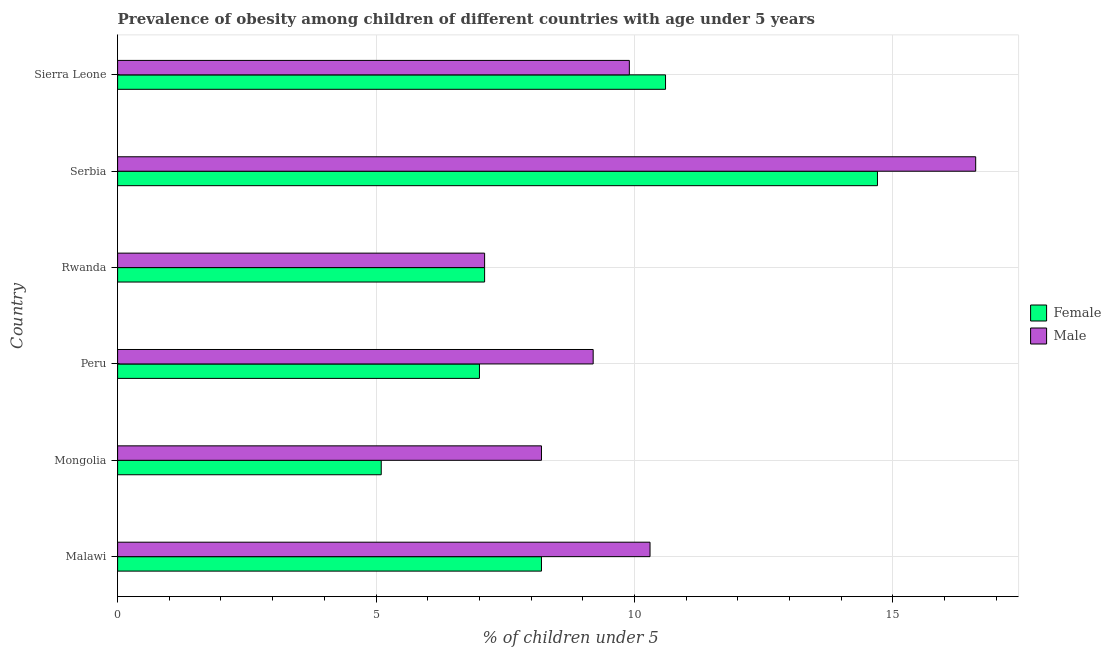How many different coloured bars are there?
Offer a terse response. 2. How many bars are there on the 1st tick from the bottom?
Your answer should be very brief. 2. What is the label of the 6th group of bars from the top?
Provide a short and direct response. Malawi. In how many cases, is the number of bars for a given country not equal to the number of legend labels?
Provide a succinct answer. 0. What is the percentage of obese female children in Malawi?
Ensure brevity in your answer.  8.2. Across all countries, what is the maximum percentage of obese female children?
Give a very brief answer. 14.7. Across all countries, what is the minimum percentage of obese male children?
Give a very brief answer. 7.1. In which country was the percentage of obese male children maximum?
Offer a terse response. Serbia. In which country was the percentage of obese female children minimum?
Offer a very short reply. Mongolia. What is the total percentage of obese female children in the graph?
Make the answer very short. 52.7. What is the difference between the percentage of obese female children in Rwanda and that in Serbia?
Make the answer very short. -7.6. What is the difference between the percentage of obese female children in Serbia and the percentage of obese male children in Malawi?
Ensure brevity in your answer.  4.4. What is the average percentage of obese female children per country?
Provide a short and direct response. 8.78. What is the difference between the percentage of obese female children and percentage of obese male children in Serbia?
Ensure brevity in your answer.  -1.9. What is the ratio of the percentage of obese female children in Peru to that in Rwanda?
Your response must be concise. 0.99. Is the percentage of obese female children in Peru less than that in Rwanda?
Your answer should be very brief. Yes. Is the difference between the percentage of obese female children in Serbia and Sierra Leone greater than the difference between the percentage of obese male children in Serbia and Sierra Leone?
Give a very brief answer. No. What does the 2nd bar from the bottom in Sierra Leone represents?
Your response must be concise. Male. How many bars are there?
Keep it short and to the point. 12. How many countries are there in the graph?
Offer a very short reply. 6. Does the graph contain any zero values?
Your response must be concise. No. How many legend labels are there?
Your answer should be very brief. 2. How are the legend labels stacked?
Ensure brevity in your answer.  Vertical. What is the title of the graph?
Offer a very short reply. Prevalence of obesity among children of different countries with age under 5 years. Does "Merchandise exports" appear as one of the legend labels in the graph?
Ensure brevity in your answer.  No. What is the label or title of the X-axis?
Your response must be concise.  % of children under 5. What is the label or title of the Y-axis?
Ensure brevity in your answer.  Country. What is the  % of children under 5 of Female in Malawi?
Ensure brevity in your answer.  8.2. What is the  % of children under 5 of Male in Malawi?
Your answer should be very brief. 10.3. What is the  % of children under 5 in Female in Mongolia?
Offer a very short reply. 5.1. What is the  % of children under 5 in Male in Mongolia?
Provide a succinct answer. 8.2. What is the  % of children under 5 in Male in Peru?
Give a very brief answer. 9.2. What is the  % of children under 5 of Female in Rwanda?
Your answer should be compact. 7.1. What is the  % of children under 5 in Male in Rwanda?
Offer a terse response. 7.1. What is the  % of children under 5 in Female in Serbia?
Keep it short and to the point. 14.7. What is the  % of children under 5 of Male in Serbia?
Your answer should be very brief. 16.6. What is the  % of children under 5 of Female in Sierra Leone?
Make the answer very short. 10.6. What is the  % of children under 5 in Male in Sierra Leone?
Give a very brief answer. 9.9. Across all countries, what is the maximum  % of children under 5 of Female?
Your response must be concise. 14.7. Across all countries, what is the maximum  % of children under 5 of Male?
Your answer should be compact. 16.6. Across all countries, what is the minimum  % of children under 5 in Female?
Offer a very short reply. 5.1. Across all countries, what is the minimum  % of children under 5 of Male?
Your answer should be compact. 7.1. What is the total  % of children under 5 in Female in the graph?
Make the answer very short. 52.7. What is the total  % of children under 5 of Male in the graph?
Your answer should be compact. 61.3. What is the difference between the  % of children under 5 in Male in Malawi and that in Mongolia?
Your answer should be compact. 2.1. What is the difference between the  % of children under 5 in Female in Malawi and that in Peru?
Offer a terse response. 1.2. What is the difference between the  % of children under 5 of Female in Malawi and that in Sierra Leone?
Your response must be concise. -2.4. What is the difference between the  % of children under 5 in Female in Mongolia and that in Peru?
Provide a succinct answer. -1.9. What is the difference between the  % of children under 5 of Male in Mongolia and that in Peru?
Ensure brevity in your answer.  -1. What is the difference between the  % of children under 5 of Female in Mongolia and that in Rwanda?
Your answer should be compact. -2. What is the difference between the  % of children under 5 of Female in Mongolia and that in Serbia?
Provide a succinct answer. -9.6. What is the difference between the  % of children under 5 in Male in Peru and that in Rwanda?
Provide a short and direct response. 2.1. What is the difference between the  % of children under 5 of Female in Peru and that in Serbia?
Offer a very short reply. -7.7. What is the difference between the  % of children under 5 of Male in Peru and that in Serbia?
Your answer should be compact. -7.4. What is the difference between the  % of children under 5 of Female in Peru and that in Sierra Leone?
Provide a succinct answer. -3.6. What is the difference between the  % of children under 5 of Male in Rwanda and that in Serbia?
Your answer should be very brief. -9.5. What is the difference between the  % of children under 5 of Female in Serbia and that in Sierra Leone?
Offer a very short reply. 4.1. What is the difference between the  % of children under 5 of Female in Mongolia and the  % of children under 5 of Male in Peru?
Provide a succinct answer. -4.1. What is the difference between the  % of children under 5 in Female in Mongolia and the  % of children under 5 in Male in Rwanda?
Keep it short and to the point. -2. What is the difference between the  % of children under 5 of Female in Peru and the  % of children under 5 of Male in Rwanda?
Provide a short and direct response. -0.1. What is the difference between the  % of children under 5 in Female in Peru and the  % of children under 5 in Male in Sierra Leone?
Give a very brief answer. -2.9. What is the difference between the  % of children under 5 in Female in Rwanda and the  % of children under 5 in Male in Sierra Leone?
Your answer should be compact. -2.8. What is the average  % of children under 5 of Female per country?
Give a very brief answer. 8.78. What is the average  % of children under 5 in Male per country?
Ensure brevity in your answer.  10.22. What is the difference between the  % of children under 5 in Female and  % of children under 5 in Male in Malawi?
Your response must be concise. -2.1. What is the ratio of the  % of children under 5 of Female in Malawi to that in Mongolia?
Offer a very short reply. 1.61. What is the ratio of the  % of children under 5 in Male in Malawi to that in Mongolia?
Make the answer very short. 1.26. What is the ratio of the  % of children under 5 in Female in Malawi to that in Peru?
Keep it short and to the point. 1.17. What is the ratio of the  % of children under 5 in Male in Malawi to that in Peru?
Make the answer very short. 1.12. What is the ratio of the  % of children under 5 in Female in Malawi to that in Rwanda?
Your response must be concise. 1.15. What is the ratio of the  % of children under 5 of Male in Malawi to that in Rwanda?
Give a very brief answer. 1.45. What is the ratio of the  % of children under 5 in Female in Malawi to that in Serbia?
Your response must be concise. 0.56. What is the ratio of the  % of children under 5 of Male in Malawi to that in Serbia?
Give a very brief answer. 0.62. What is the ratio of the  % of children under 5 of Female in Malawi to that in Sierra Leone?
Give a very brief answer. 0.77. What is the ratio of the  % of children under 5 of Male in Malawi to that in Sierra Leone?
Ensure brevity in your answer.  1.04. What is the ratio of the  % of children under 5 in Female in Mongolia to that in Peru?
Offer a terse response. 0.73. What is the ratio of the  % of children under 5 in Male in Mongolia to that in Peru?
Offer a terse response. 0.89. What is the ratio of the  % of children under 5 in Female in Mongolia to that in Rwanda?
Ensure brevity in your answer.  0.72. What is the ratio of the  % of children under 5 of Male in Mongolia to that in Rwanda?
Ensure brevity in your answer.  1.15. What is the ratio of the  % of children under 5 in Female in Mongolia to that in Serbia?
Give a very brief answer. 0.35. What is the ratio of the  % of children under 5 of Male in Mongolia to that in Serbia?
Ensure brevity in your answer.  0.49. What is the ratio of the  % of children under 5 in Female in Mongolia to that in Sierra Leone?
Provide a succinct answer. 0.48. What is the ratio of the  % of children under 5 in Male in Mongolia to that in Sierra Leone?
Keep it short and to the point. 0.83. What is the ratio of the  % of children under 5 of Female in Peru to that in Rwanda?
Offer a very short reply. 0.99. What is the ratio of the  % of children under 5 of Male in Peru to that in Rwanda?
Ensure brevity in your answer.  1.3. What is the ratio of the  % of children under 5 in Female in Peru to that in Serbia?
Your answer should be very brief. 0.48. What is the ratio of the  % of children under 5 of Male in Peru to that in Serbia?
Give a very brief answer. 0.55. What is the ratio of the  % of children under 5 in Female in Peru to that in Sierra Leone?
Give a very brief answer. 0.66. What is the ratio of the  % of children under 5 of Male in Peru to that in Sierra Leone?
Offer a very short reply. 0.93. What is the ratio of the  % of children under 5 of Female in Rwanda to that in Serbia?
Your response must be concise. 0.48. What is the ratio of the  % of children under 5 in Male in Rwanda to that in Serbia?
Your response must be concise. 0.43. What is the ratio of the  % of children under 5 in Female in Rwanda to that in Sierra Leone?
Your answer should be compact. 0.67. What is the ratio of the  % of children under 5 in Male in Rwanda to that in Sierra Leone?
Your response must be concise. 0.72. What is the ratio of the  % of children under 5 in Female in Serbia to that in Sierra Leone?
Provide a short and direct response. 1.39. What is the ratio of the  % of children under 5 in Male in Serbia to that in Sierra Leone?
Offer a terse response. 1.68. What is the difference between the highest and the second highest  % of children under 5 of Male?
Give a very brief answer. 6.3. 